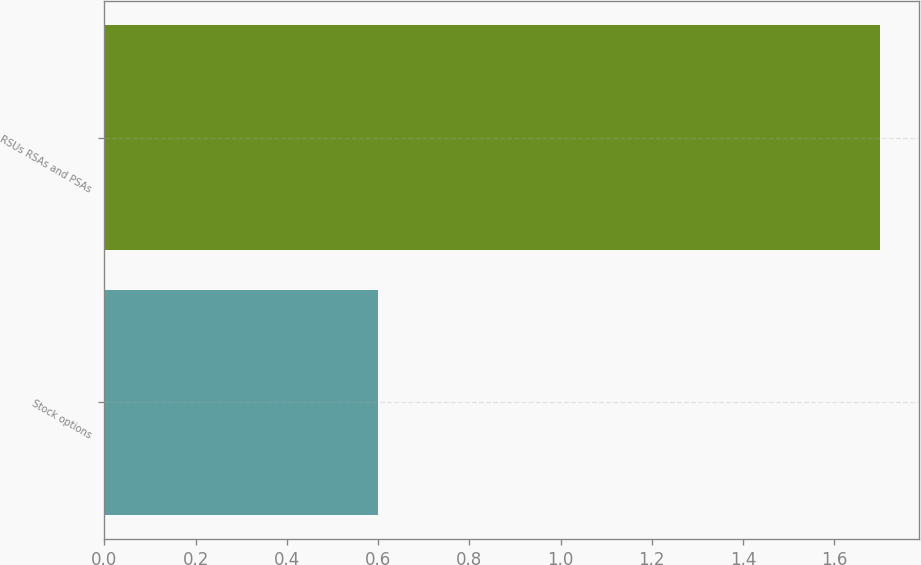Convert chart to OTSL. <chart><loc_0><loc_0><loc_500><loc_500><bar_chart><fcel>Stock options<fcel>RSUs RSAs and PSAs<nl><fcel>0.6<fcel>1.7<nl></chart> 